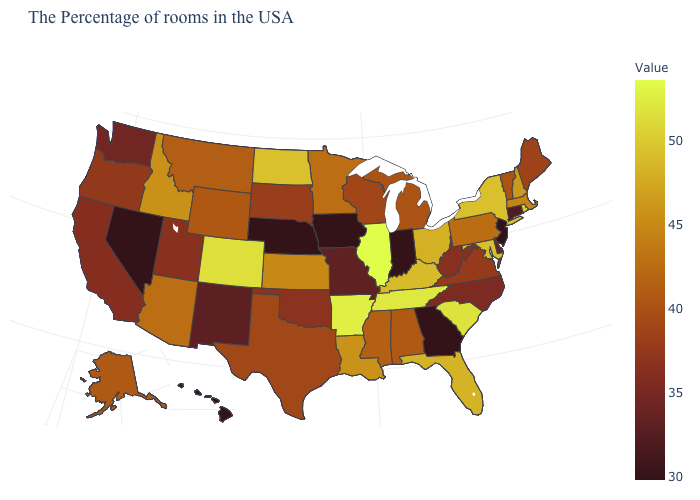Among the states that border Georgia , which have the highest value?
Concise answer only. Tennessee. Does the map have missing data?
Quick response, please. No. Which states have the lowest value in the West?
Short answer required. Nevada, Hawaii. Does Utah have the lowest value in the West?
Write a very short answer. No. Does Kentucky have a higher value than Oklahoma?
Keep it brief. Yes. 